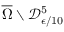Convert formula to latex. <formula><loc_0><loc_0><loc_500><loc_500>\overline { \Omega } \ \mathcal { D } _ { \epsilon / 1 0 } ^ { 5 }</formula> 